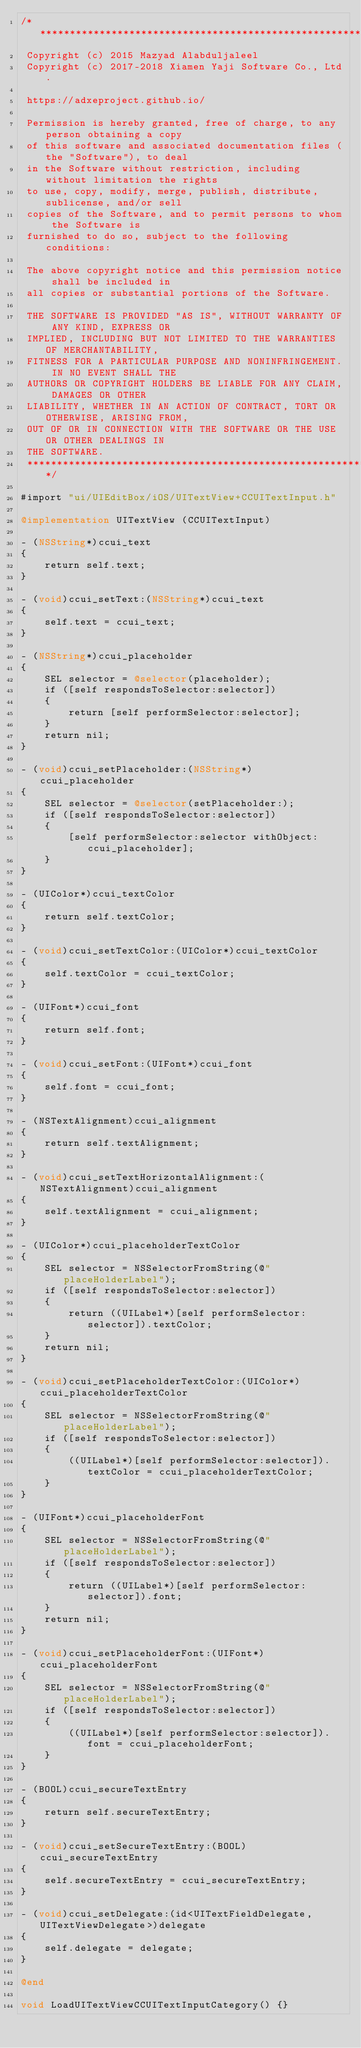<code> <loc_0><loc_0><loc_500><loc_500><_ObjectiveC_>/****************************************************************************
 Copyright (c) 2015 Mazyad Alabduljaleel
 Copyright (c) 2017-2018 Xiamen Yaji Software Co., Ltd.

 https://adxeproject.github.io/

 Permission is hereby granted, free of charge, to any person obtaining a copy
 of this software and associated documentation files (the "Software"), to deal
 in the Software without restriction, including without limitation the rights
 to use, copy, modify, merge, publish, distribute, sublicense, and/or sell
 copies of the Software, and to permit persons to whom the Software is
 furnished to do so, subject to the following conditions:

 The above copyright notice and this permission notice shall be included in
 all copies or substantial portions of the Software.

 THE SOFTWARE IS PROVIDED "AS IS", WITHOUT WARRANTY OF ANY KIND, EXPRESS OR
 IMPLIED, INCLUDING BUT NOT LIMITED TO THE WARRANTIES OF MERCHANTABILITY,
 FITNESS FOR A PARTICULAR PURPOSE AND NONINFRINGEMENT. IN NO EVENT SHALL THE
 AUTHORS OR COPYRIGHT HOLDERS BE LIABLE FOR ANY CLAIM, DAMAGES OR OTHER
 LIABILITY, WHETHER IN AN ACTION OF CONTRACT, TORT OR OTHERWISE, ARISING FROM,
 OUT OF OR IN CONNECTION WITH THE SOFTWARE OR THE USE OR OTHER DEALINGS IN
 THE SOFTWARE.
 ****************************************************************************/

#import "ui/UIEditBox/iOS/UITextView+CCUITextInput.h"

@implementation UITextView (CCUITextInput)

- (NSString*)ccui_text
{
    return self.text;
}

- (void)ccui_setText:(NSString*)ccui_text
{
    self.text = ccui_text;
}

- (NSString*)ccui_placeholder
{
    SEL selector = @selector(placeholder);
    if ([self respondsToSelector:selector])
    {
        return [self performSelector:selector];
    }
    return nil;
}

- (void)ccui_setPlaceholder:(NSString*)ccui_placeholder
{
    SEL selector = @selector(setPlaceholder:);
    if ([self respondsToSelector:selector])
    {
        [self performSelector:selector withObject:ccui_placeholder];
    }
}

- (UIColor*)ccui_textColor
{
    return self.textColor;
}

- (void)ccui_setTextColor:(UIColor*)ccui_textColor
{
    self.textColor = ccui_textColor;
}

- (UIFont*)ccui_font
{
    return self.font;
}

- (void)ccui_setFont:(UIFont*)ccui_font
{
    self.font = ccui_font;
}

- (NSTextAlignment)ccui_alignment
{
    return self.textAlignment;
}

- (void)ccui_setTextHorizontalAlignment:(NSTextAlignment)ccui_alignment
{
    self.textAlignment = ccui_alignment;
}

- (UIColor*)ccui_placeholderTextColor
{
    SEL selector = NSSelectorFromString(@"placeHolderLabel");
    if ([self respondsToSelector:selector])
    {
        return ((UILabel*)[self performSelector:selector]).textColor;
    }
    return nil;
}

- (void)ccui_setPlaceholderTextColor:(UIColor*)ccui_placeholderTextColor
{
    SEL selector = NSSelectorFromString(@"placeHolderLabel");
    if ([self respondsToSelector:selector])
    {
        ((UILabel*)[self performSelector:selector]).textColor = ccui_placeholderTextColor;
    }
}

- (UIFont*)ccui_placeholderFont
{
    SEL selector = NSSelectorFromString(@"placeHolderLabel");
    if ([self respondsToSelector:selector])
    {
        return ((UILabel*)[self performSelector:selector]).font;
    }
    return nil;
}

- (void)ccui_setPlaceholderFont:(UIFont*)ccui_placeholderFont
{
    SEL selector = NSSelectorFromString(@"placeHolderLabel");
    if ([self respondsToSelector:selector])
    {
        ((UILabel*)[self performSelector:selector]).font = ccui_placeholderFont;
    }
}

- (BOOL)ccui_secureTextEntry
{
    return self.secureTextEntry;
}

- (void)ccui_setSecureTextEntry:(BOOL)ccui_secureTextEntry
{
    self.secureTextEntry = ccui_secureTextEntry;
}

- (void)ccui_setDelegate:(id<UITextFieldDelegate, UITextViewDelegate>)delegate
{
    self.delegate = delegate;
}

@end

void LoadUITextViewCCUITextInputCategory() {}
</code> 